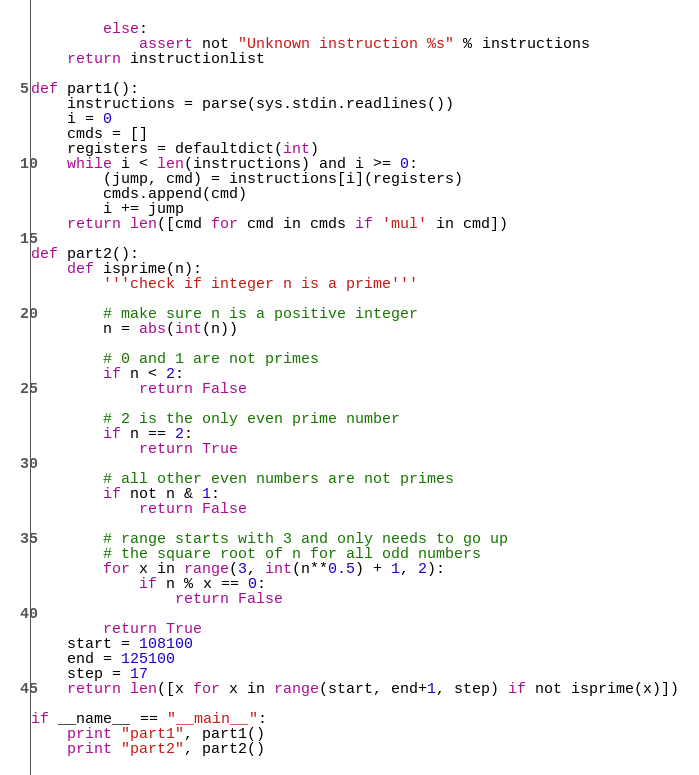Convert code to text. <code><loc_0><loc_0><loc_500><loc_500><_Python_>        else:
            assert not "Unknown instruction %s" % instructions
    return instructionlist

def part1():
    instructions = parse(sys.stdin.readlines())
    i = 0
    cmds = []
    registers = defaultdict(int)
    while i < len(instructions) and i >= 0:
        (jump, cmd) = instructions[i](registers)
        cmds.append(cmd)
        i += jump
    return len([cmd for cmd in cmds if 'mul' in cmd])

def part2():
    def isprime(n):
        '''check if integer n is a prime'''

        # make sure n is a positive integer
        n = abs(int(n))

        # 0 and 1 are not primes
        if n < 2:
            return False

        # 2 is the only even prime number
        if n == 2:
            return True

        # all other even numbers are not primes
        if not n & 1:
            return False

        # range starts with 3 and only needs to go up
        # the square root of n for all odd numbers
        for x in range(3, int(n**0.5) + 1, 2):
            if n % x == 0:
                return False

        return True
    start = 108100
    end = 125100
    step = 17
    return len([x for x in range(start, end+1, step) if not isprime(x)])

if __name__ == "__main__":
    print "part1", part1()
    print "part2", part2()
</code> 